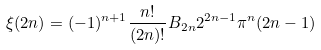<formula> <loc_0><loc_0><loc_500><loc_500>\xi ( 2 n ) = ( - 1 ) ^ { n + 1 } { \frac { n ! } { ( 2 n ) ! } } B _ { 2 n } 2 ^ { 2 n - 1 } \pi ^ { n } ( 2 n - 1 )</formula> 